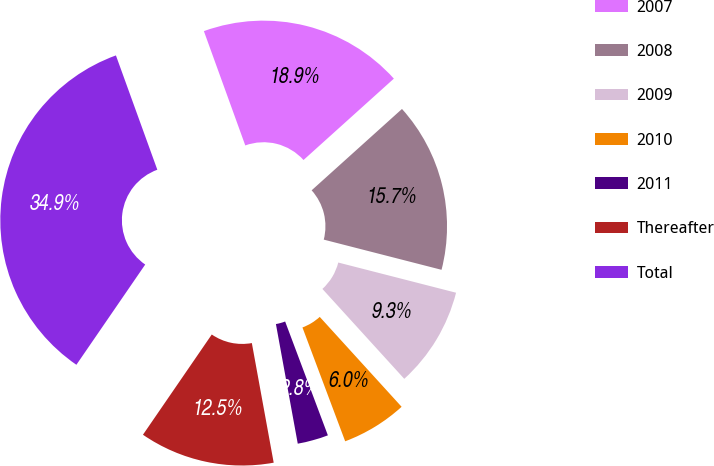Convert chart to OTSL. <chart><loc_0><loc_0><loc_500><loc_500><pie_chart><fcel>2007<fcel>2008<fcel>2009<fcel>2010<fcel>2011<fcel>Thereafter<fcel>Total<nl><fcel>18.86%<fcel>15.66%<fcel>9.25%<fcel>6.04%<fcel>2.84%<fcel>12.45%<fcel>34.89%<nl></chart> 